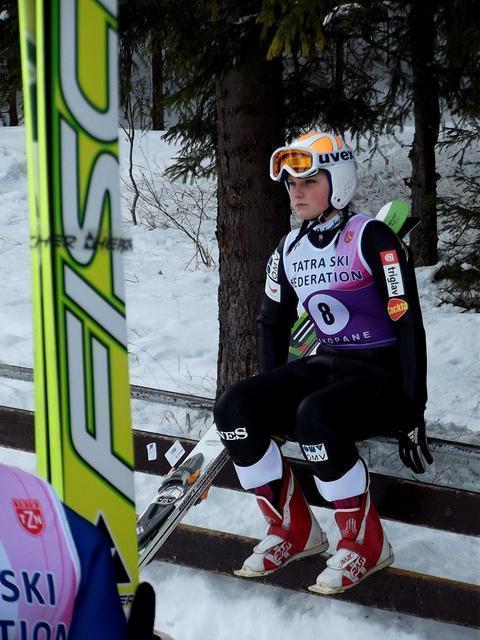What is the child wearing?
Make your selection from the four choices given to correctly answer the question.
Options: Purse, goggles, crown, backpack. Goggles. 